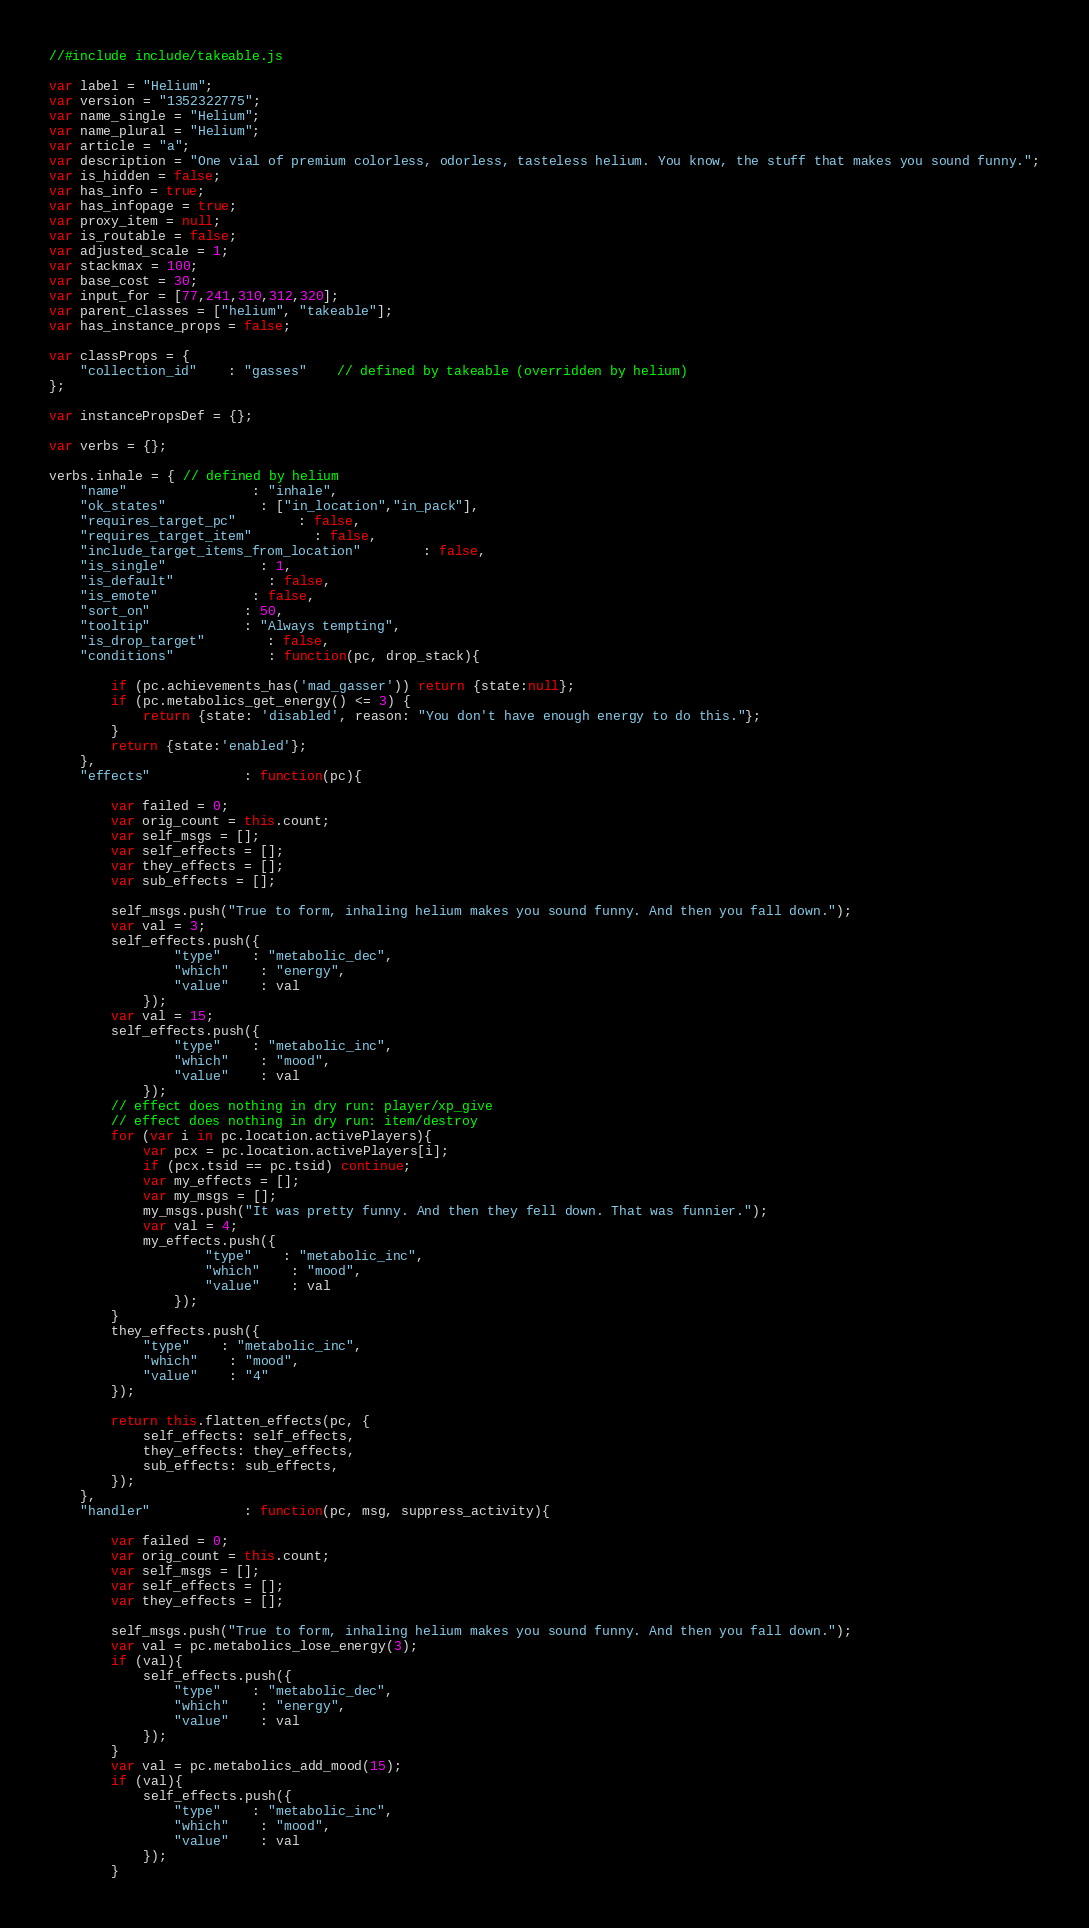<code> <loc_0><loc_0><loc_500><loc_500><_JavaScript_>//#include include/takeable.js

var label = "Helium";
var version = "1352322775";
var name_single = "Helium";
var name_plural = "Helium";
var article = "a";
var description = "One vial of premium colorless, odorless, tasteless helium. You know, the stuff that makes you sound funny.";
var is_hidden = false;
var has_info = true;
var has_infopage = true;
var proxy_item = null;
var is_routable = false;
var adjusted_scale = 1;
var stackmax = 100;
var base_cost = 30;
var input_for = [77,241,310,312,320];
var parent_classes = ["helium", "takeable"];
var has_instance_props = false;

var classProps = {
	"collection_id"	: "gasses"	// defined by takeable (overridden by helium)
};

var instancePropsDef = {};

var verbs = {};

verbs.inhale = { // defined by helium
	"name"				: "inhale",
	"ok_states"			: ["in_location","in_pack"],
	"requires_target_pc"		: false,
	"requires_target_item"		: false,
	"include_target_items_from_location"		: false,
	"is_single"			: 1,
	"is_default"			: false,
	"is_emote"			: false,
	"sort_on"			: 50,
	"tooltip"			: "Always tempting",
	"is_drop_target"		: false,
	"conditions"			: function(pc, drop_stack){

		if (pc.achievements_has('mad_gasser')) return {state:null};
		if (pc.metabolics_get_energy() <= 3) {
			return {state: 'disabled', reason: "You don't have enough energy to do this."};
		}
		return {state:'enabled'};
	},
	"effects"			: function(pc){

		var failed = 0;
		var orig_count = this.count;
		var self_msgs = [];
		var self_effects = [];
		var they_effects = [];
		var sub_effects = [];

		self_msgs.push("True to form, inhaling helium makes you sound funny. And then you fall down.");
		var val = 3;
		self_effects.push({
				"type"	: "metabolic_dec",
				"which"	: "energy",
				"value"	: val
			});
		var val = 15;
		self_effects.push({
				"type"	: "metabolic_inc",
				"which"	: "mood",
				"value"	: val
			});
		// effect does nothing in dry run: player/xp_give
		// effect does nothing in dry run: item/destroy
		for (var i in pc.location.activePlayers){
			var pcx = pc.location.activePlayers[i];
			if (pcx.tsid == pc.tsid) continue;
			var my_effects = [];
			var my_msgs = [];
			my_msgs.push("It was pretty funny. And then they fell down. That was funnier.");
			var val = 4;
			my_effects.push({
					"type"	: "metabolic_inc",
					"which"	: "mood",
					"value"	: val
				});
		}
		they_effects.push({
			"type"	: "metabolic_inc",
			"which"	: "mood",
			"value"	: "4"
		});

		return this.flatten_effects(pc, {
			self_effects: self_effects,
			they_effects: they_effects,
			sub_effects: sub_effects,
		});
	},
	"handler"			: function(pc, msg, suppress_activity){

		var failed = 0;
		var orig_count = this.count;
		var self_msgs = [];
		var self_effects = [];
		var they_effects = [];

		self_msgs.push("True to form, inhaling helium makes you sound funny. And then you fall down.");
		var val = pc.metabolics_lose_energy(3);
		if (val){
			self_effects.push({
				"type"	: "metabolic_dec",
				"which"	: "energy",
				"value"	: val
			});
		}
		var val = pc.metabolics_add_mood(15);
		if (val){
			self_effects.push({
				"type"	: "metabolic_inc",
				"which"	: "mood",
				"value"	: val
			});
		}</code> 